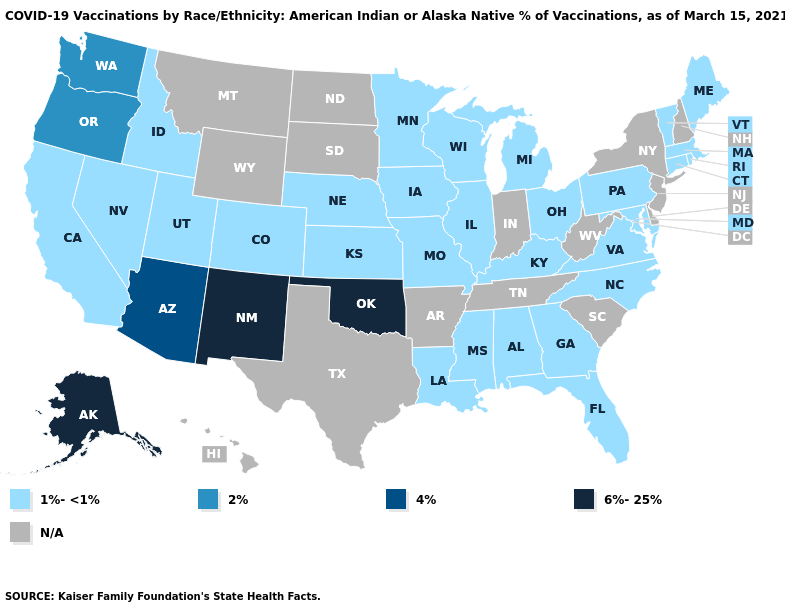Among the states that border Oregon , does Washington have the lowest value?
Write a very short answer. No. Which states hav the highest value in the Northeast?
Concise answer only. Connecticut, Maine, Massachusetts, Pennsylvania, Rhode Island, Vermont. Does the map have missing data?
Short answer required. Yes. What is the lowest value in the USA?
Quick response, please. 1%-<1%. What is the value of Wisconsin?
Write a very short answer. 1%-<1%. Name the states that have a value in the range N/A?
Answer briefly. Arkansas, Delaware, Hawaii, Indiana, Montana, New Hampshire, New Jersey, New York, North Dakota, South Carolina, South Dakota, Tennessee, Texas, West Virginia, Wyoming. Name the states that have a value in the range N/A?
Concise answer only. Arkansas, Delaware, Hawaii, Indiana, Montana, New Hampshire, New Jersey, New York, North Dakota, South Carolina, South Dakota, Tennessee, Texas, West Virginia, Wyoming. What is the lowest value in states that border New York?
Be succinct. 1%-<1%. What is the lowest value in the USA?
Write a very short answer. 1%-<1%. Name the states that have a value in the range 6%-25%?
Short answer required. Alaska, New Mexico, Oklahoma. What is the value of California?
Concise answer only. 1%-<1%. Does the first symbol in the legend represent the smallest category?
Short answer required. Yes. What is the highest value in the USA?
Answer briefly. 6%-25%. 